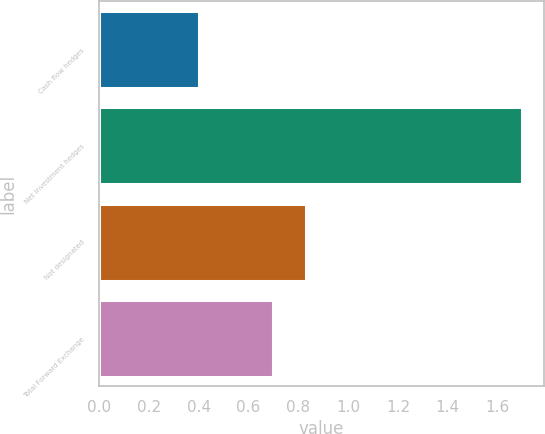Convert chart. <chart><loc_0><loc_0><loc_500><loc_500><bar_chart><fcel>Cash flow hedges<fcel>Net investment hedges<fcel>Not designated<fcel>Total Forward Exchange<nl><fcel>0.4<fcel>1.7<fcel>0.83<fcel>0.7<nl></chart> 